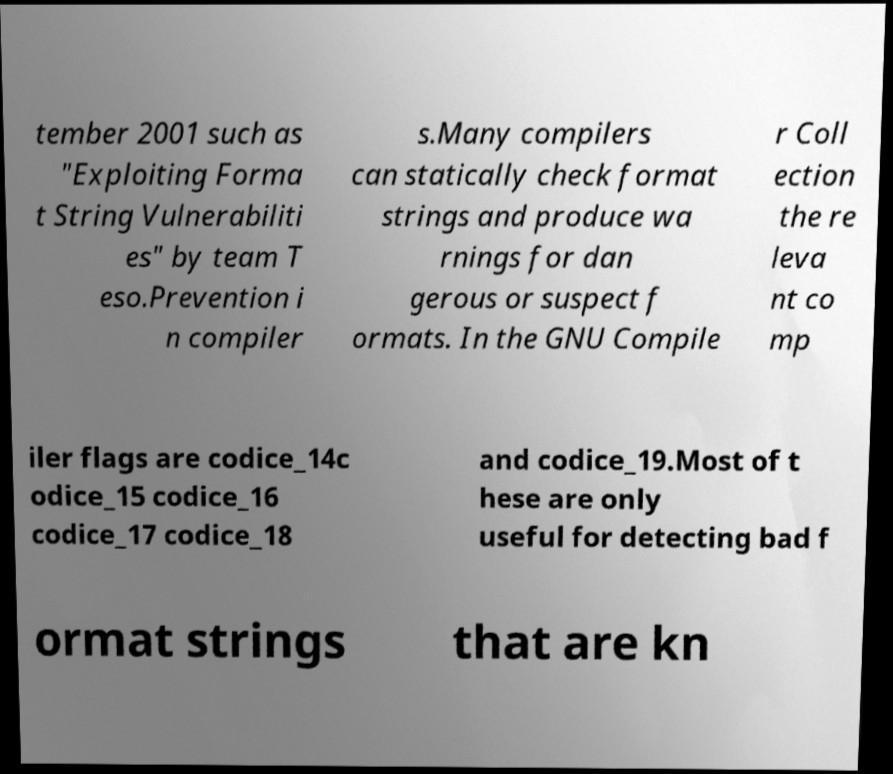Could you extract and type out the text from this image? tember 2001 such as "Exploiting Forma t String Vulnerabiliti es" by team T eso.Prevention i n compiler s.Many compilers can statically check format strings and produce wa rnings for dan gerous or suspect f ormats. In the GNU Compile r Coll ection the re leva nt co mp iler flags are codice_14c odice_15 codice_16 codice_17 codice_18 and codice_19.Most of t hese are only useful for detecting bad f ormat strings that are kn 